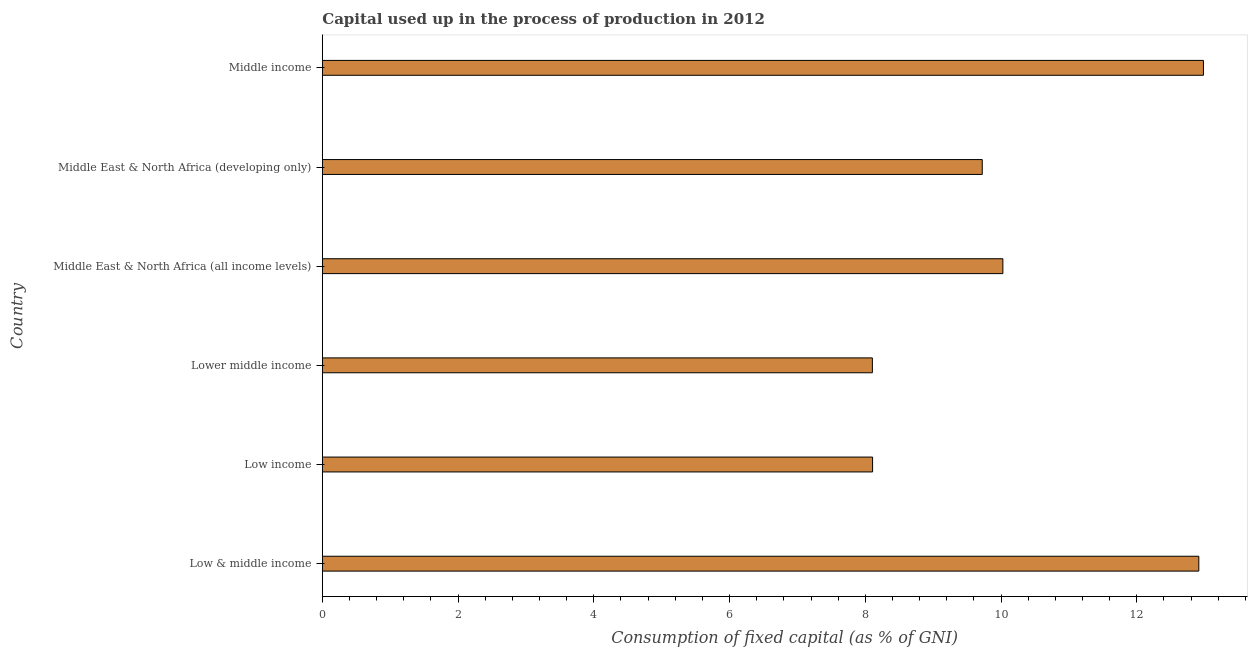Does the graph contain any zero values?
Offer a terse response. No. What is the title of the graph?
Your answer should be compact. Capital used up in the process of production in 2012. What is the label or title of the X-axis?
Offer a terse response. Consumption of fixed capital (as % of GNI). What is the consumption of fixed capital in Lower middle income?
Offer a terse response. 8.1. Across all countries, what is the maximum consumption of fixed capital?
Ensure brevity in your answer.  12.98. Across all countries, what is the minimum consumption of fixed capital?
Give a very brief answer. 8.1. In which country was the consumption of fixed capital minimum?
Ensure brevity in your answer.  Lower middle income. What is the sum of the consumption of fixed capital?
Offer a terse response. 61.86. What is the difference between the consumption of fixed capital in Low & middle income and Middle East & North Africa (all income levels)?
Offer a very short reply. 2.89. What is the average consumption of fixed capital per country?
Offer a very short reply. 10.31. What is the median consumption of fixed capital?
Offer a terse response. 9.88. What is the ratio of the consumption of fixed capital in Middle East & North Africa (developing only) to that in Middle income?
Ensure brevity in your answer.  0.75. Is the consumption of fixed capital in Low & middle income less than that in Middle East & North Africa (developing only)?
Offer a very short reply. No. Is the difference between the consumption of fixed capital in Low & middle income and Middle East & North Africa (developing only) greater than the difference between any two countries?
Make the answer very short. No. What is the difference between the highest and the second highest consumption of fixed capital?
Ensure brevity in your answer.  0.07. What is the difference between the highest and the lowest consumption of fixed capital?
Your answer should be compact. 4.88. In how many countries, is the consumption of fixed capital greater than the average consumption of fixed capital taken over all countries?
Offer a very short reply. 2. How many bars are there?
Your answer should be compact. 6. Are all the bars in the graph horizontal?
Provide a succinct answer. Yes. What is the difference between two consecutive major ticks on the X-axis?
Make the answer very short. 2. Are the values on the major ticks of X-axis written in scientific E-notation?
Your response must be concise. No. What is the Consumption of fixed capital (as % of GNI) of Low & middle income?
Your response must be concise. 12.91. What is the Consumption of fixed capital (as % of GNI) in Low income?
Keep it short and to the point. 8.11. What is the Consumption of fixed capital (as % of GNI) of Lower middle income?
Provide a succinct answer. 8.1. What is the Consumption of fixed capital (as % of GNI) of Middle East & North Africa (all income levels)?
Ensure brevity in your answer.  10.03. What is the Consumption of fixed capital (as % of GNI) of Middle East & North Africa (developing only)?
Make the answer very short. 9.72. What is the Consumption of fixed capital (as % of GNI) in Middle income?
Your answer should be very brief. 12.98. What is the difference between the Consumption of fixed capital (as % of GNI) in Low & middle income and Low income?
Keep it short and to the point. 4.81. What is the difference between the Consumption of fixed capital (as % of GNI) in Low & middle income and Lower middle income?
Your answer should be compact. 4.81. What is the difference between the Consumption of fixed capital (as % of GNI) in Low & middle income and Middle East & North Africa (all income levels)?
Your response must be concise. 2.89. What is the difference between the Consumption of fixed capital (as % of GNI) in Low & middle income and Middle East & North Africa (developing only)?
Make the answer very short. 3.19. What is the difference between the Consumption of fixed capital (as % of GNI) in Low & middle income and Middle income?
Give a very brief answer. -0.07. What is the difference between the Consumption of fixed capital (as % of GNI) in Low income and Lower middle income?
Ensure brevity in your answer.  0. What is the difference between the Consumption of fixed capital (as % of GNI) in Low income and Middle East & North Africa (all income levels)?
Provide a short and direct response. -1.92. What is the difference between the Consumption of fixed capital (as % of GNI) in Low income and Middle East & North Africa (developing only)?
Keep it short and to the point. -1.62. What is the difference between the Consumption of fixed capital (as % of GNI) in Low income and Middle income?
Offer a terse response. -4.87. What is the difference between the Consumption of fixed capital (as % of GNI) in Lower middle income and Middle East & North Africa (all income levels)?
Your answer should be very brief. -1.92. What is the difference between the Consumption of fixed capital (as % of GNI) in Lower middle income and Middle East & North Africa (developing only)?
Make the answer very short. -1.62. What is the difference between the Consumption of fixed capital (as % of GNI) in Lower middle income and Middle income?
Provide a succinct answer. -4.88. What is the difference between the Consumption of fixed capital (as % of GNI) in Middle East & North Africa (all income levels) and Middle East & North Africa (developing only)?
Provide a short and direct response. 0.3. What is the difference between the Consumption of fixed capital (as % of GNI) in Middle East & North Africa (all income levels) and Middle income?
Ensure brevity in your answer.  -2.95. What is the difference between the Consumption of fixed capital (as % of GNI) in Middle East & North Africa (developing only) and Middle income?
Offer a terse response. -3.26. What is the ratio of the Consumption of fixed capital (as % of GNI) in Low & middle income to that in Low income?
Make the answer very short. 1.59. What is the ratio of the Consumption of fixed capital (as % of GNI) in Low & middle income to that in Lower middle income?
Your answer should be very brief. 1.59. What is the ratio of the Consumption of fixed capital (as % of GNI) in Low & middle income to that in Middle East & North Africa (all income levels)?
Keep it short and to the point. 1.29. What is the ratio of the Consumption of fixed capital (as % of GNI) in Low & middle income to that in Middle East & North Africa (developing only)?
Give a very brief answer. 1.33. What is the ratio of the Consumption of fixed capital (as % of GNI) in Low income to that in Lower middle income?
Ensure brevity in your answer.  1. What is the ratio of the Consumption of fixed capital (as % of GNI) in Low income to that in Middle East & North Africa (all income levels)?
Provide a succinct answer. 0.81. What is the ratio of the Consumption of fixed capital (as % of GNI) in Low income to that in Middle East & North Africa (developing only)?
Offer a very short reply. 0.83. What is the ratio of the Consumption of fixed capital (as % of GNI) in Low income to that in Middle income?
Your response must be concise. 0.62. What is the ratio of the Consumption of fixed capital (as % of GNI) in Lower middle income to that in Middle East & North Africa (all income levels)?
Your answer should be compact. 0.81. What is the ratio of the Consumption of fixed capital (as % of GNI) in Lower middle income to that in Middle East & North Africa (developing only)?
Ensure brevity in your answer.  0.83. What is the ratio of the Consumption of fixed capital (as % of GNI) in Lower middle income to that in Middle income?
Provide a short and direct response. 0.62. What is the ratio of the Consumption of fixed capital (as % of GNI) in Middle East & North Africa (all income levels) to that in Middle East & North Africa (developing only)?
Give a very brief answer. 1.03. What is the ratio of the Consumption of fixed capital (as % of GNI) in Middle East & North Africa (all income levels) to that in Middle income?
Your response must be concise. 0.77. What is the ratio of the Consumption of fixed capital (as % of GNI) in Middle East & North Africa (developing only) to that in Middle income?
Your answer should be very brief. 0.75. 